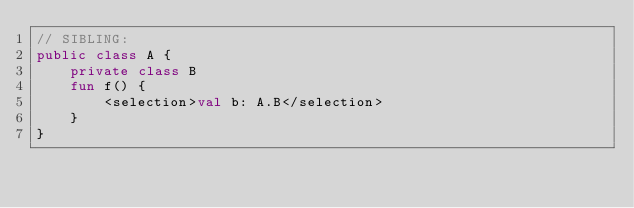Convert code to text. <code><loc_0><loc_0><loc_500><loc_500><_Kotlin_>// SIBLING:
public class A {
    private class B
    fun f() {
        <selection>val b: A.B</selection>
    }
}</code> 